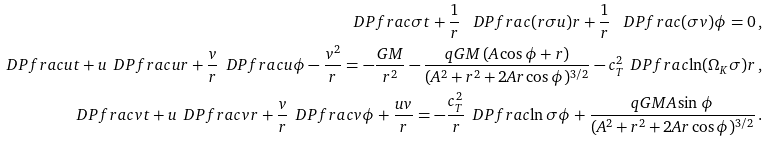Convert formula to latex. <formula><loc_0><loc_0><loc_500><loc_500>\ D P f r a c { \sigma } { t } + \frac { 1 } { r } \, \ D P f r a c { ( r \sigma u ) } { r } + \frac { 1 } { r } \, \ D P f r a c { ( \sigma v ) } { \phi } = 0 \, , \\ \ D P f r a c { u } { t } + u \, \ D P f r a c { u } { r } + \frac { v } { r } \, \ D P f r a c { u } { \phi } - \frac { v ^ { 2 } } { r } = - \frac { G M } { r ^ { 2 } } - \frac { q G M \, ( A \cos \phi + r ) } { ( A ^ { 2 } + r ^ { 2 } + 2 A r \cos \phi ) ^ { 3 / 2 } } - c _ { T } ^ { 2 } \, \ D P f r a c { \ln ( \Omega _ { K } \sigma ) } { r } \, , \\ \ D P f r a c { v } { t } + u \, \ D P f r a c { v } { r } + \frac { v } { r } \, \ D P f r a c { v } { \phi } + \frac { u v } { r } = - \frac { c _ { T } ^ { 2 } } { r } \, \ D P f r a c { \ln \sigma } { \phi } + \frac { q G M A \sin \phi } { ( A ^ { 2 } + r ^ { 2 } + 2 A r \cos \phi ) ^ { 3 / 2 } } \, .</formula> 